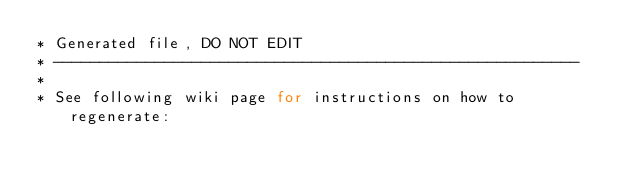<code> <loc_0><loc_0><loc_500><loc_500><_Java_>* Generated file, DO NOT EDIT
* ---------------------------------------------------------
*
* See following wiki page for instructions on how to regenerate:</code> 